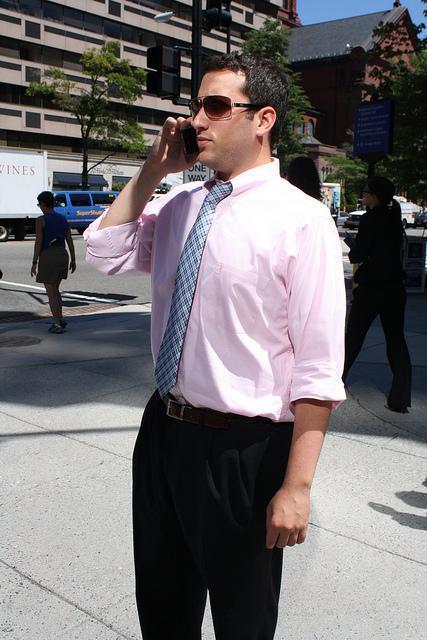How many people are there?
Give a very brief answer. 3. How many horses are there?
Give a very brief answer. 0. 